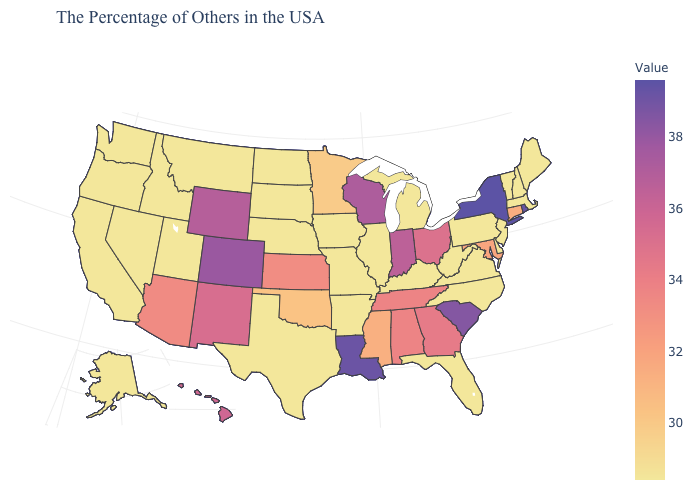Does Colorado have the highest value in the West?
Concise answer only. Yes. Is the legend a continuous bar?
Write a very short answer. Yes. Among the states that border South Dakota , which have the highest value?
Concise answer only. Wyoming. Does Alaska have the lowest value in the USA?
Be succinct. Yes. Does the map have missing data?
Concise answer only. No. Which states have the lowest value in the USA?
Quick response, please. Maine, Massachusetts, New Hampshire, Vermont, New Jersey, Delaware, Pennsylvania, Virginia, North Carolina, West Virginia, Florida, Michigan, Kentucky, Illinois, Missouri, Arkansas, Iowa, Nebraska, Texas, South Dakota, North Dakota, Utah, Montana, Idaho, Nevada, California, Washington, Oregon, Alaska. 